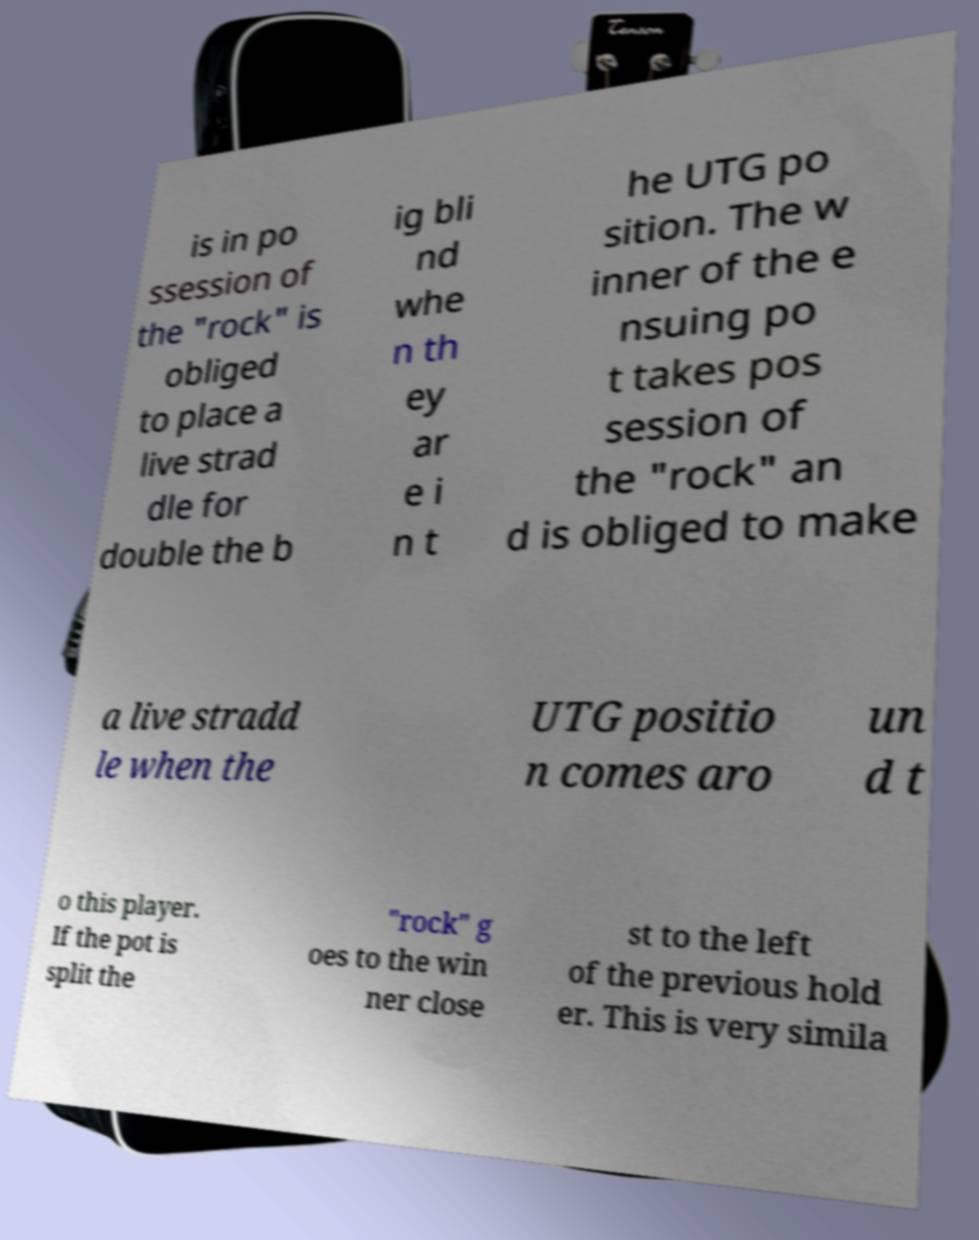What messages or text are displayed in this image? I need them in a readable, typed format. is in po ssession of the "rock" is obliged to place a live strad dle for double the b ig bli nd whe n th ey ar e i n t he UTG po sition. The w inner of the e nsuing po t takes pos session of the "rock" an d is obliged to make a live stradd le when the UTG positio n comes aro un d t o this player. If the pot is split the "rock" g oes to the win ner close st to the left of the previous hold er. This is very simila 